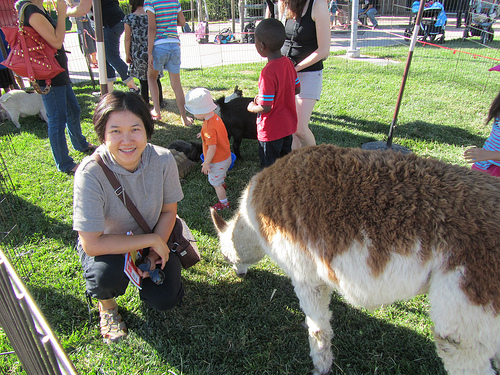Please provide the bounding box coordinate of the region this sentence describes: person has on athletic shoe. The bounding box coordinates for the region where the person has on an athletic shoe are [0.18, 0.73, 0.26, 0.82]. 